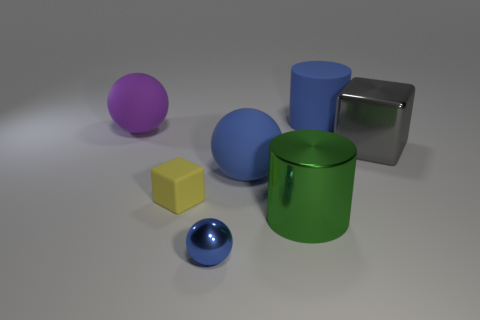Is the blue ball in front of the green object made of the same material as the large gray object? It appears that the blue ball and the large gray object both exhibit a similar reflective sheen, suggesting that they could be made of a similar material, such as a type of polished metal or plastic. However, without additional information on the composition or context, we cannot determine with certainty if they are indeed made of the exact same material. 